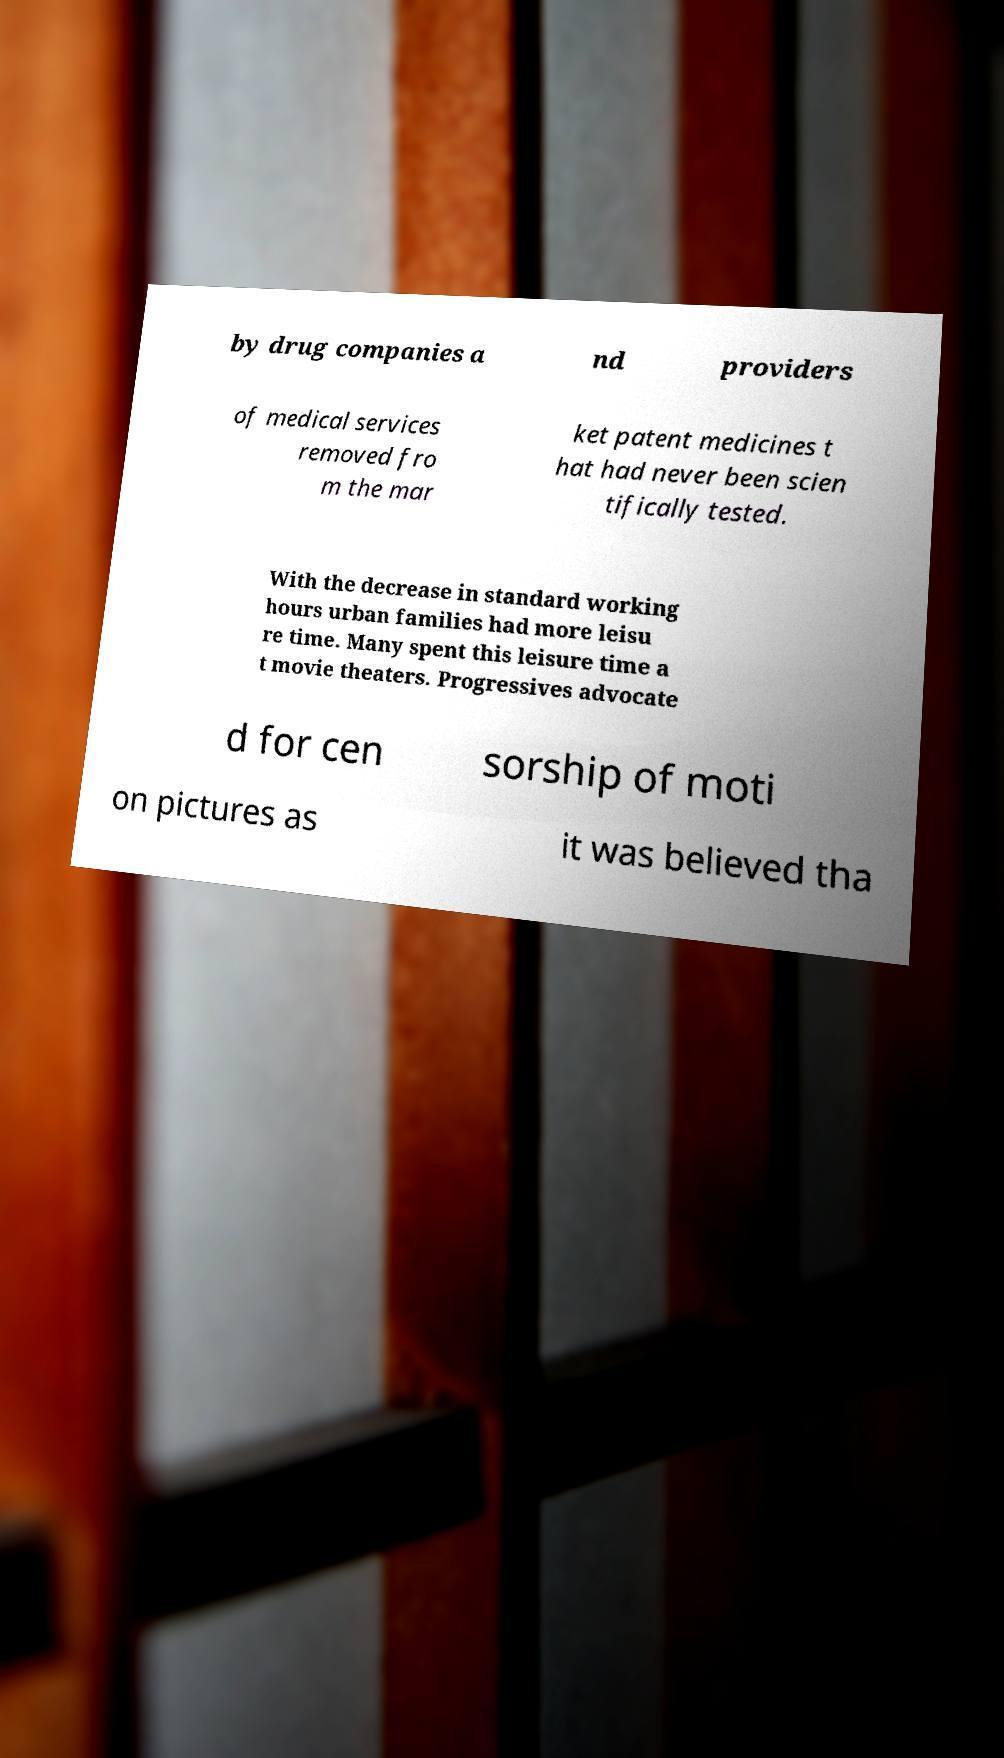Could you extract and type out the text from this image? by drug companies a nd providers of medical services removed fro m the mar ket patent medicines t hat had never been scien tifically tested. With the decrease in standard working hours urban families had more leisu re time. Many spent this leisure time a t movie theaters. Progressives advocate d for cen sorship of moti on pictures as it was believed tha 